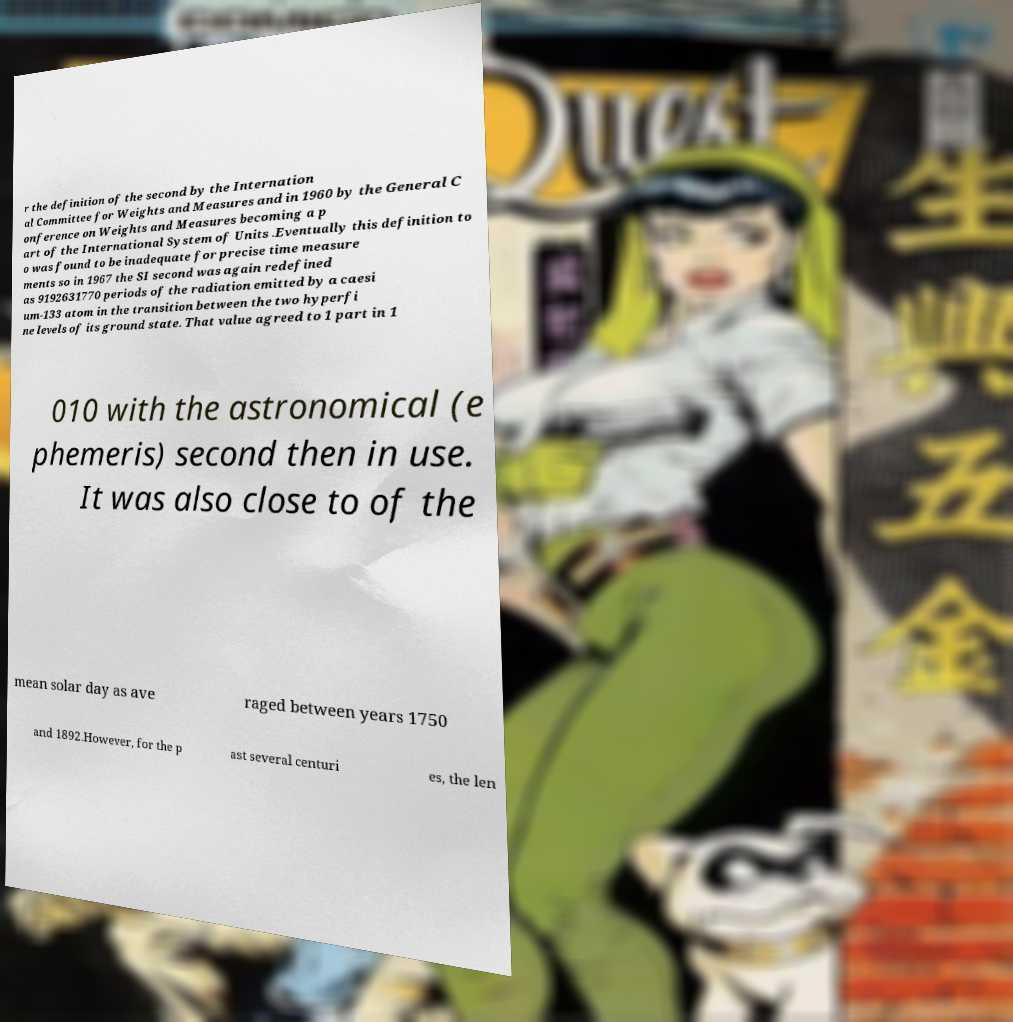There's text embedded in this image that I need extracted. Can you transcribe it verbatim? r the definition of the second by the Internation al Committee for Weights and Measures and in 1960 by the General C onference on Weights and Measures becoming a p art of the International System of Units .Eventually this definition to o was found to be inadequate for precise time measure ments so in 1967 the SI second was again redefined as 9192631770 periods of the radiation emitted by a caesi um-133 atom in the transition between the two hyperfi ne levels of its ground state. That value agreed to 1 part in 1 010 with the astronomical (e phemeris) second then in use. It was also close to of the mean solar day as ave raged between years 1750 and 1892.However, for the p ast several centuri es, the len 